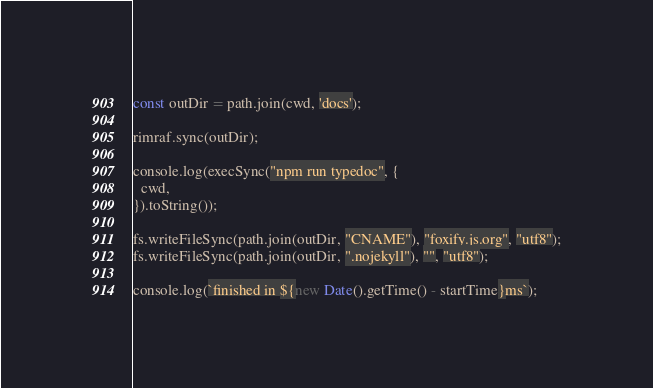<code> <loc_0><loc_0><loc_500><loc_500><_JavaScript_>const outDir = path.join(cwd, 'docs');

rimraf.sync(outDir);

console.log(execSync("npm run typedoc", {
  cwd,
}).toString());

fs.writeFileSync(path.join(outDir, "CNAME"), "foxify.js.org", "utf8");
fs.writeFileSync(path.join(outDir, ".nojekyll"), "", "utf8");

console.log(`finished in ${new Date().getTime() - startTime}ms`);</code> 